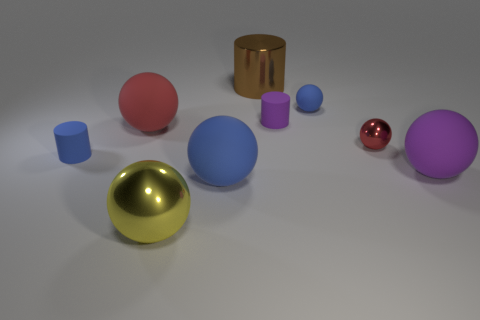What might be the size of these objects relative to each other? Though it's challenging to ascertain precise sizes without a reference, the objects appear to be similar in scale to each other, with the spheres roughly the same diameter and the cylindrical and cubic shapes similar in height to the sphere diameter, suggesting a deliberate setup for either aesthetic or comparative purposes. 